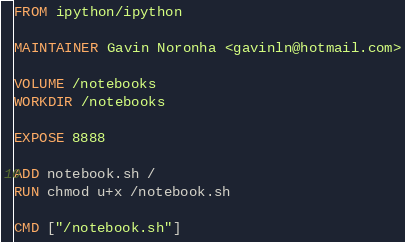<code> <loc_0><loc_0><loc_500><loc_500><_Dockerfile_>FROM ipython/ipython

MAINTAINER Gavin Noronha <gavinln@hotmail.com>

VOLUME /notebooks
WORKDIR /notebooks

EXPOSE 8888

ADD notebook.sh /
RUN chmod u+x /notebook.sh

CMD ["/notebook.sh"]
</code> 